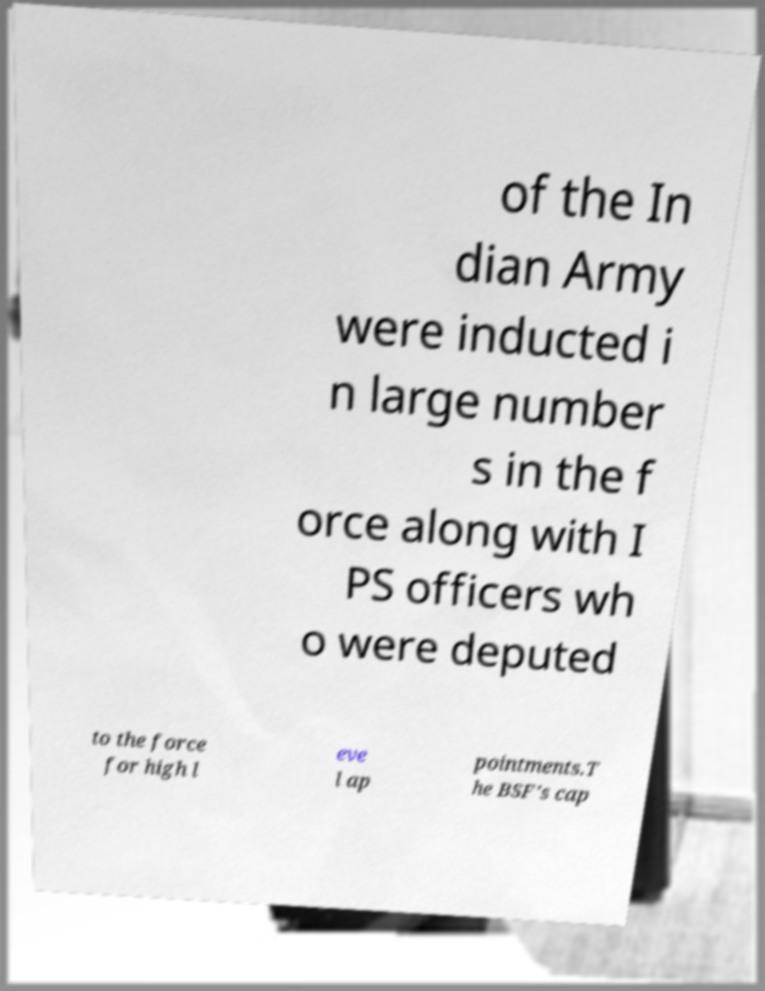Could you extract and type out the text from this image? of the In dian Army were inducted i n large number s in the f orce along with I PS officers wh o were deputed to the force for high l eve l ap pointments.T he BSF's cap 